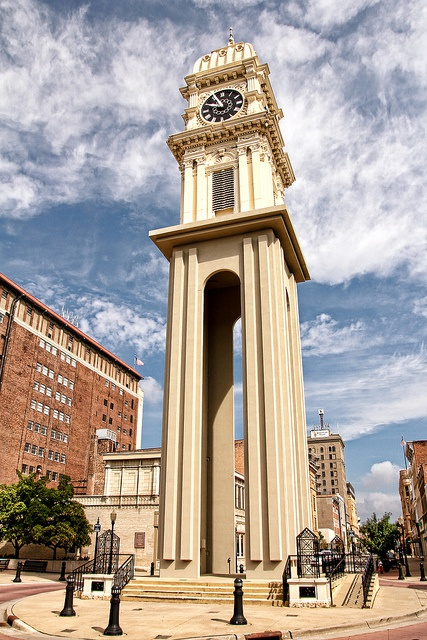Describe the objects in this image and their specific colors. I can see a clock in darkgray, black, white, and gray tones in this image. 